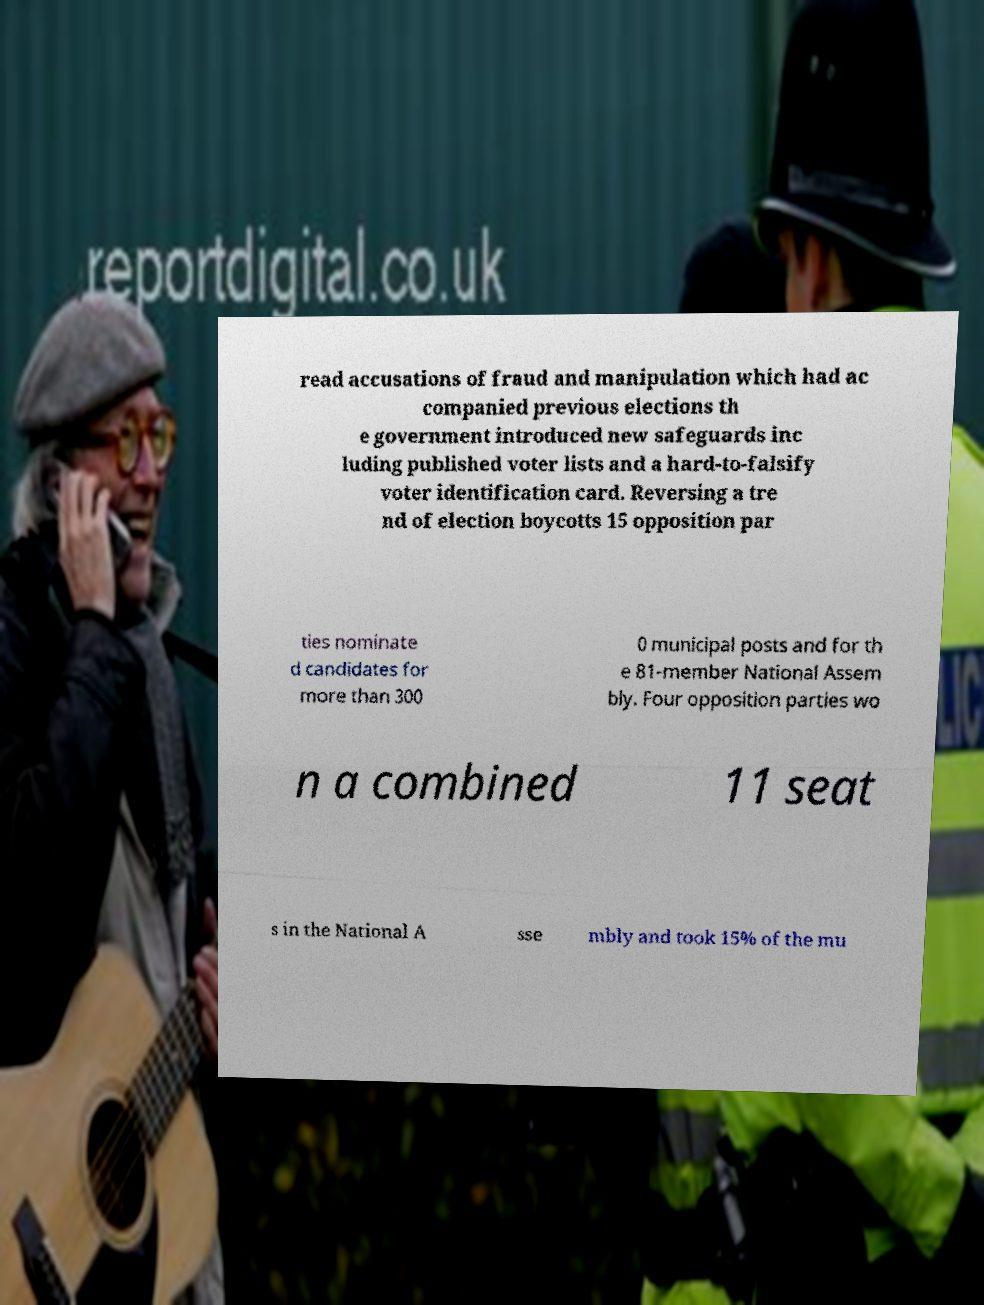Please read and relay the text visible in this image. What does it say? read accusations of fraud and manipulation which had ac companied previous elections th e government introduced new safeguards inc luding published voter lists and a hard-to-falsify voter identification card. Reversing a tre nd of election boycotts 15 opposition par ties nominate d candidates for more than 300 0 municipal posts and for th e 81-member National Assem bly. Four opposition parties wo n a combined 11 seat s in the National A sse mbly and took 15% of the mu 